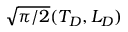Convert formula to latex. <formula><loc_0><loc_0><loc_500><loc_500>\sqrt { \pi / 2 } ( T _ { D } , L _ { D } )</formula> 